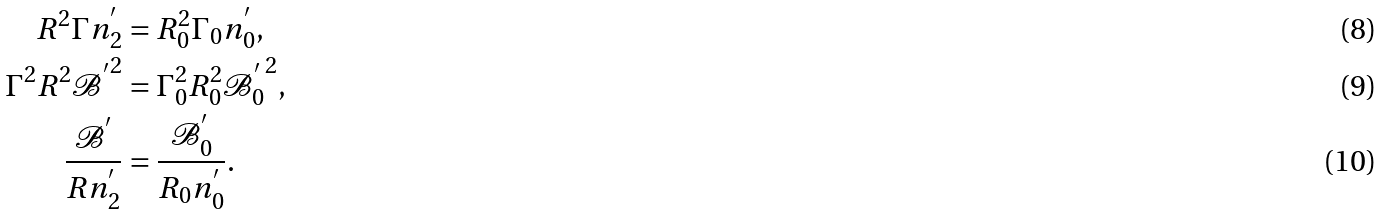Convert formula to latex. <formula><loc_0><loc_0><loc_500><loc_500>R ^ { 2 } \Gamma n _ { 2 } ^ { ^ { \prime } } & = R ^ { 2 } _ { 0 } \Gamma _ { 0 } n ^ { ^ { \prime } } _ { 0 } , \\ \Gamma ^ { 2 } R ^ { 2 } \mathcal { B ^ { ^ { \prime } } } ^ { 2 } & = \Gamma _ { 0 } ^ { 2 } R _ { 0 } ^ { 2 } { \mathcal { B } _ { 0 } ^ { ^ { \prime } } } ^ { 2 } , \\ \frac { \mathcal { B ^ { ^ { \prime } } } } { R n _ { 2 } ^ { ^ { \prime } } } & = \frac { \mathcal { B } _ { 0 } ^ { ^ { \prime } } } { R _ { 0 } n _ { 0 } ^ { ^ { \prime } } } .</formula> 